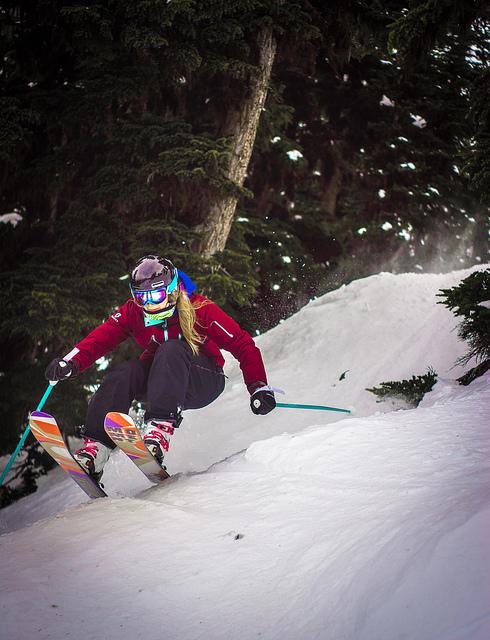Is this person snowboarding?
Be succinct. No. Are there any trees?
Keep it brief. Yes. Is she sliding down the hill?
Keep it brief. Yes. 